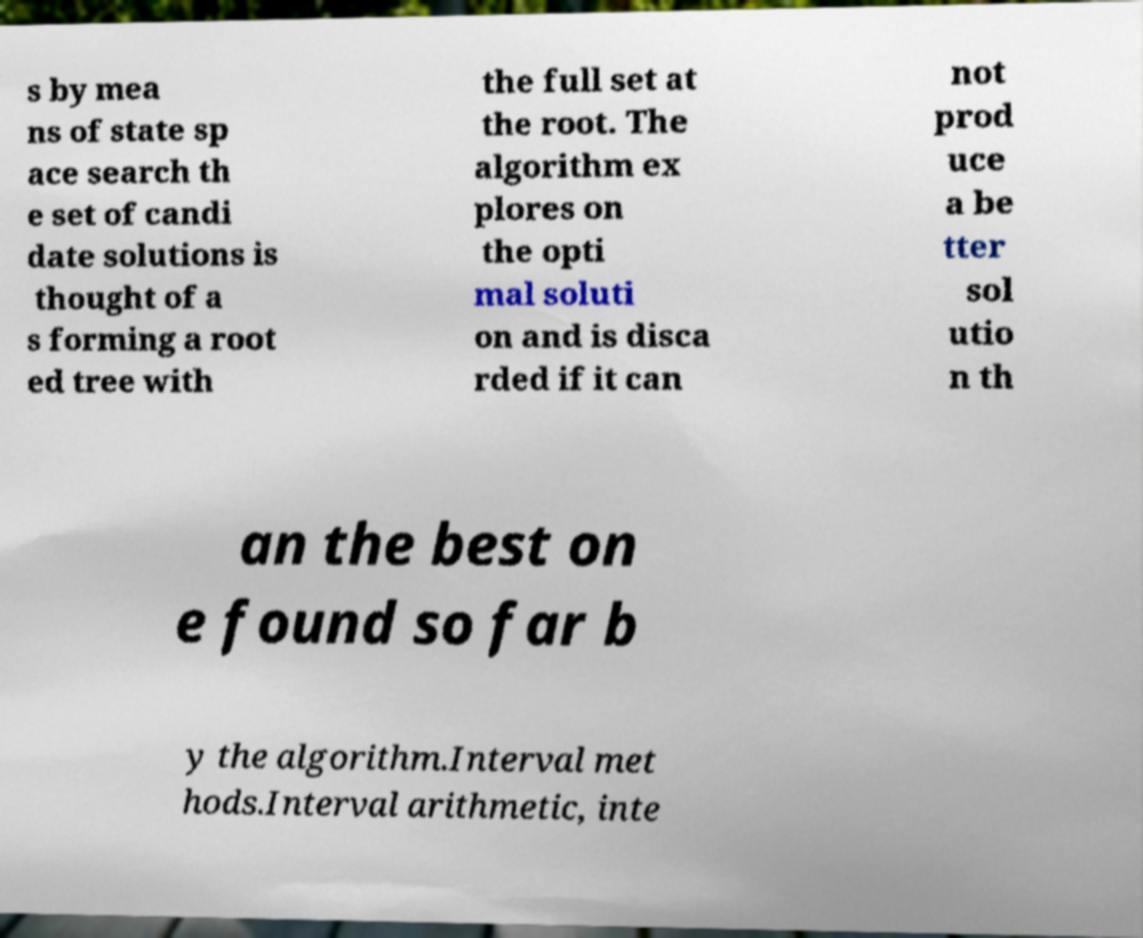Can you read and provide the text displayed in the image?This photo seems to have some interesting text. Can you extract and type it out for me? s by mea ns of state sp ace search th e set of candi date solutions is thought of a s forming a root ed tree with the full set at the root. The algorithm ex plores on the opti mal soluti on and is disca rded if it can not prod uce a be tter sol utio n th an the best on e found so far b y the algorithm.Interval met hods.Interval arithmetic, inte 